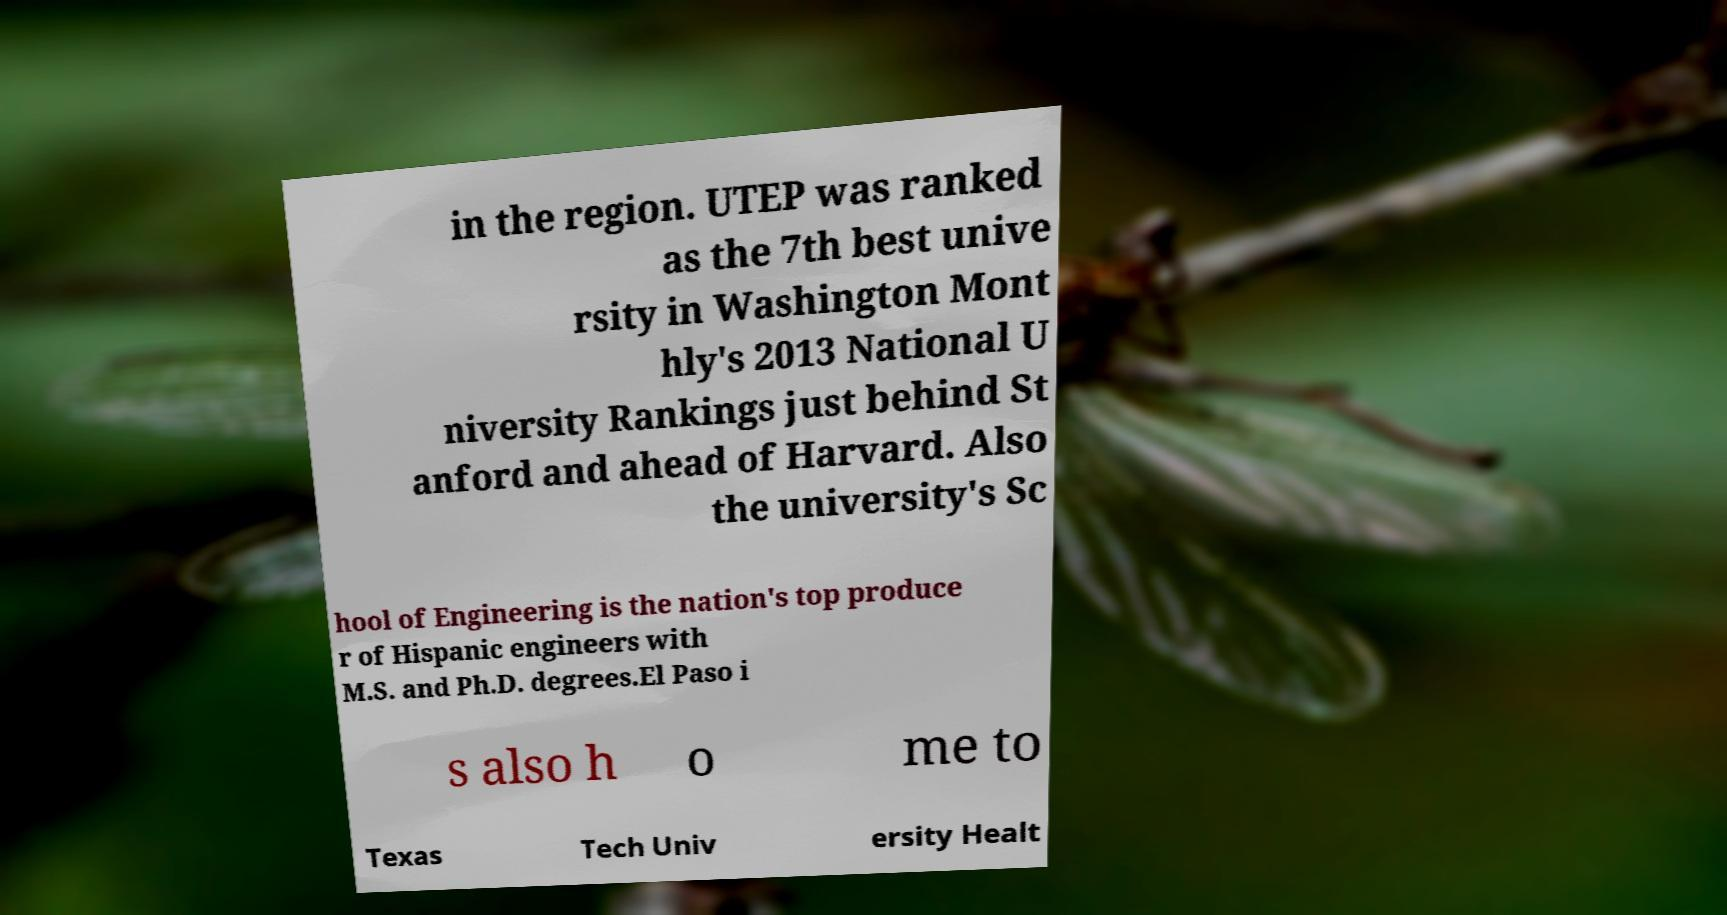For documentation purposes, I need the text within this image transcribed. Could you provide that? in the region. UTEP was ranked as the 7th best unive rsity in Washington Mont hly's 2013 National U niversity Rankings just behind St anford and ahead of Harvard. Also the university's Sc hool of Engineering is the nation's top produce r of Hispanic engineers with M.S. and Ph.D. degrees.El Paso i s also h o me to Texas Tech Univ ersity Healt 